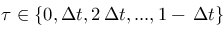Convert formula to latex. <formula><loc_0><loc_0><loc_500><loc_500>\tau \in \{ 0 , \Delta t , 2 \, \Delta t , \dots , 1 - \, \Delta t \}</formula> 